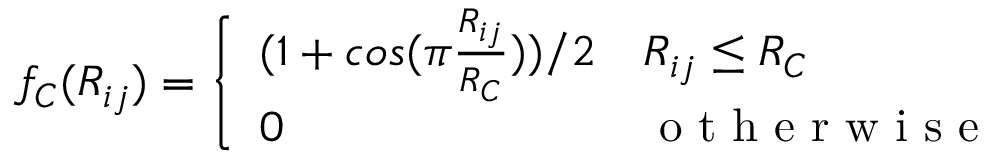Convert formula to latex. <formula><loc_0><loc_0><loc_500><loc_500>f _ { C } ( R _ { i j } ) = \left \{ \begin{array} { l l } { ( 1 + \cos ( \pi \frac { R _ { i j } } { R _ { C } } ) ) / 2 } & { R _ { i j } \leq R _ { C } } \\ { 0 } & { o t h e r w i s e } \end{array}</formula> 